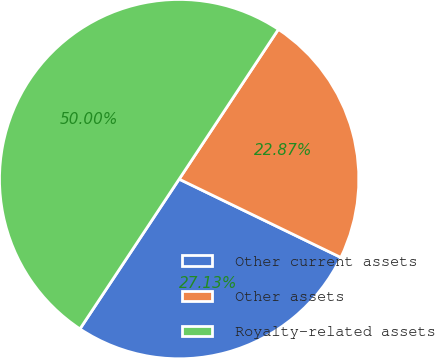Convert chart to OTSL. <chart><loc_0><loc_0><loc_500><loc_500><pie_chart><fcel>Other current assets<fcel>Other assets<fcel>Royalty-related assets<nl><fcel>27.13%<fcel>22.87%<fcel>50.0%<nl></chart> 